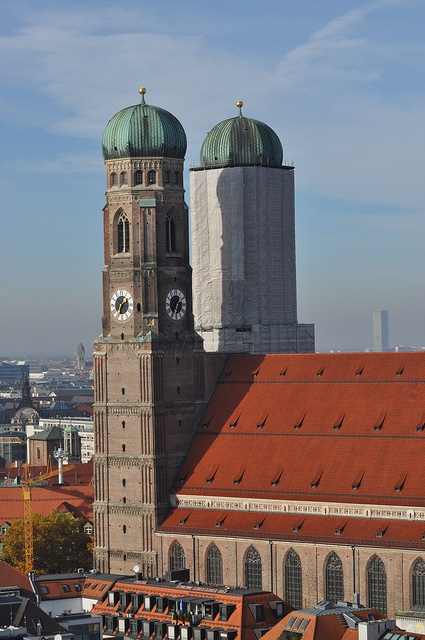Describe the objects in this image and their specific colors. I can see clock in gray, ivory, darkgray, and black tones and clock in gray and black tones in this image. 